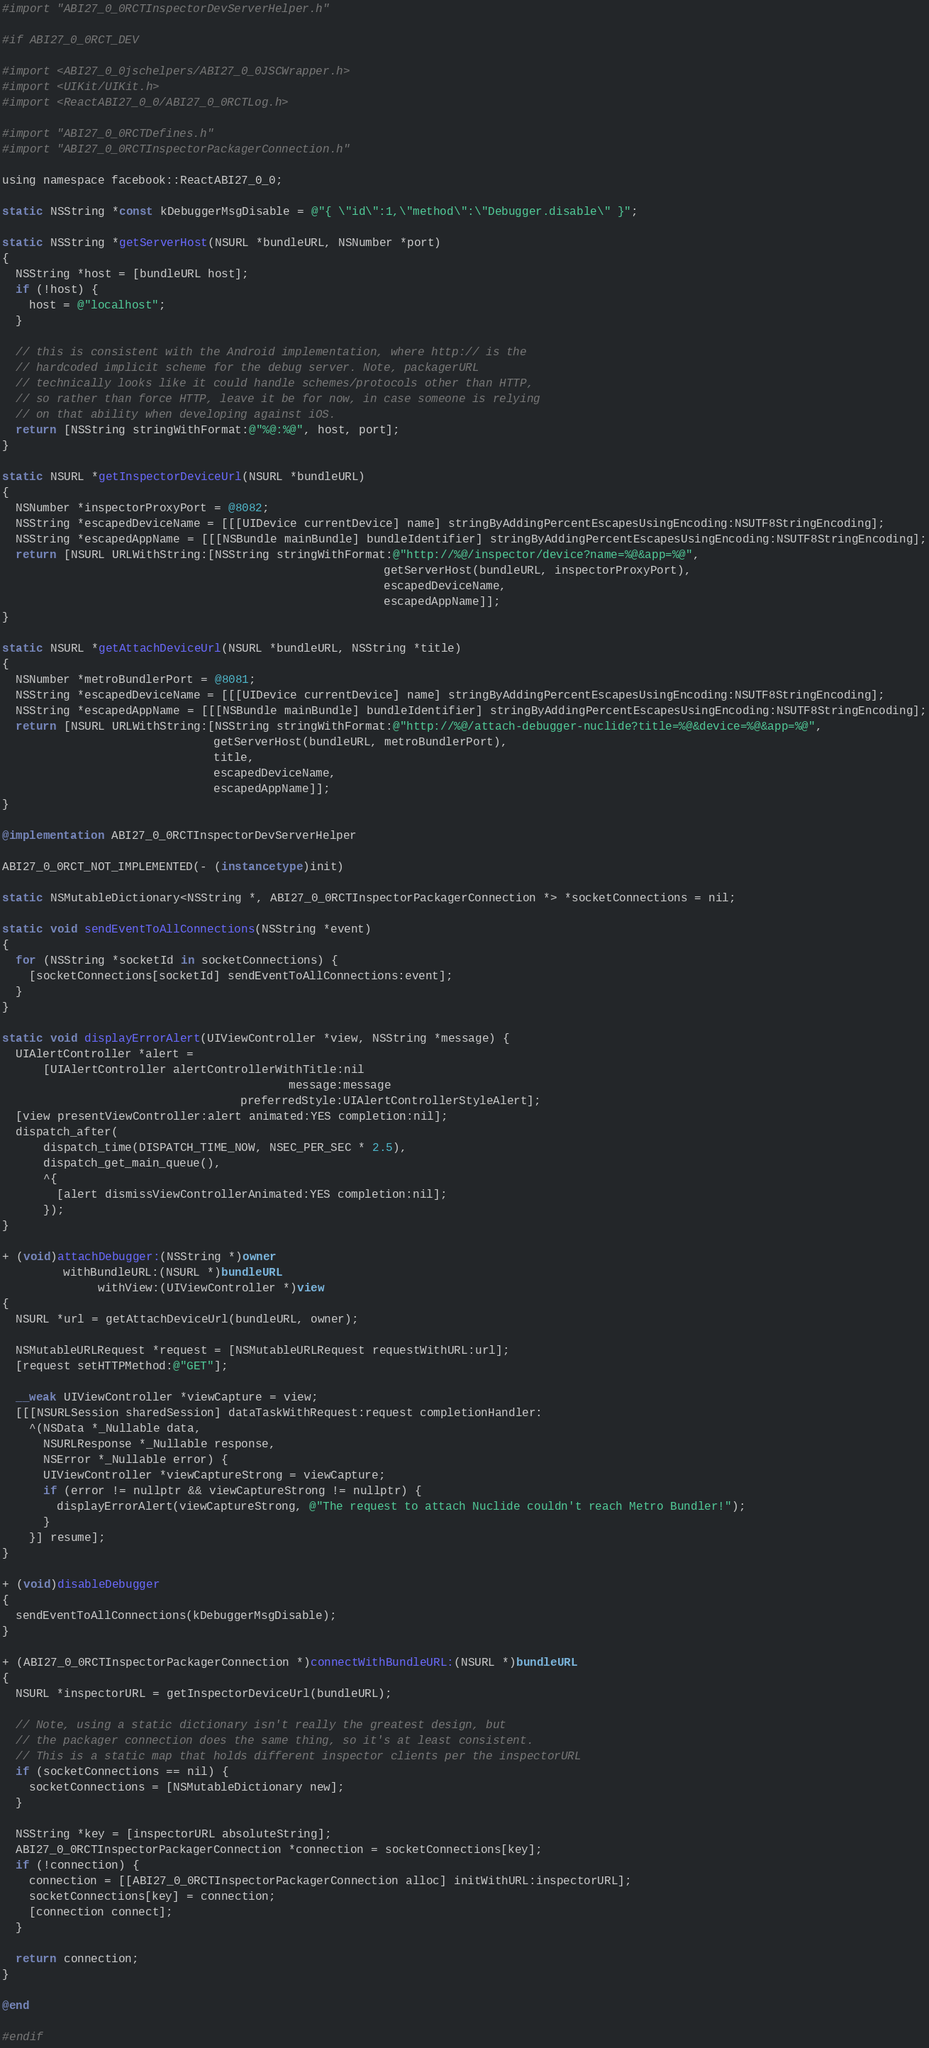<code> <loc_0><loc_0><loc_500><loc_500><_ObjectiveC_>#import "ABI27_0_0RCTInspectorDevServerHelper.h"

#if ABI27_0_0RCT_DEV

#import <ABI27_0_0jschelpers/ABI27_0_0JSCWrapper.h>
#import <UIKit/UIKit.h>
#import <ReactABI27_0_0/ABI27_0_0RCTLog.h>

#import "ABI27_0_0RCTDefines.h"
#import "ABI27_0_0RCTInspectorPackagerConnection.h"

using namespace facebook::ReactABI27_0_0;

static NSString *const kDebuggerMsgDisable = @"{ \"id\":1,\"method\":\"Debugger.disable\" }";

static NSString *getServerHost(NSURL *bundleURL, NSNumber *port)
{
  NSString *host = [bundleURL host];
  if (!host) {
    host = @"localhost";
  }

  // this is consistent with the Android implementation, where http:// is the
  // hardcoded implicit scheme for the debug server. Note, packagerURL
  // technically looks like it could handle schemes/protocols other than HTTP,
  // so rather than force HTTP, leave it be for now, in case someone is relying
  // on that ability when developing against iOS.
  return [NSString stringWithFormat:@"%@:%@", host, port];
}

static NSURL *getInspectorDeviceUrl(NSURL *bundleURL)
{
  NSNumber *inspectorProxyPort = @8082;
  NSString *escapedDeviceName = [[[UIDevice currentDevice] name] stringByAddingPercentEscapesUsingEncoding:NSUTF8StringEncoding];
  NSString *escapedAppName = [[[NSBundle mainBundle] bundleIdentifier] stringByAddingPercentEscapesUsingEncoding:NSUTF8StringEncoding];
  return [NSURL URLWithString:[NSString stringWithFormat:@"http://%@/inspector/device?name=%@&app=%@",
                                                        getServerHost(bundleURL, inspectorProxyPort),
                                                        escapedDeviceName,
                                                        escapedAppName]];
}

static NSURL *getAttachDeviceUrl(NSURL *bundleURL, NSString *title)
{
  NSNumber *metroBundlerPort = @8081;
  NSString *escapedDeviceName = [[[UIDevice currentDevice] name] stringByAddingPercentEscapesUsingEncoding:NSUTF8StringEncoding];
  NSString *escapedAppName = [[[NSBundle mainBundle] bundleIdentifier] stringByAddingPercentEscapesUsingEncoding:NSUTF8StringEncoding];
  return [NSURL URLWithString:[NSString stringWithFormat:@"http://%@/attach-debugger-nuclide?title=%@&device=%@&app=%@",
                               getServerHost(bundleURL, metroBundlerPort),
                               title,
                               escapedDeviceName,
                               escapedAppName]];
}

@implementation ABI27_0_0RCTInspectorDevServerHelper

ABI27_0_0RCT_NOT_IMPLEMENTED(- (instancetype)init)

static NSMutableDictionary<NSString *, ABI27_0_0RCTInspectorPackagerConnection *> *socketConnections = nil;

static void sendEventToAllConnections(NSString *event)
{
  for (NSString *socketId in socketConnections) {
    [socketConnections[socketId] sendEventToAllConnections:event];
  }
}

static void displayErrorAlert(UIViewController *view, NSString *message) {
  UIAlertController *alert =
      [UIAlertController alertControllerWithTitle:nil
                                          message:message
                                   preferredStyle:UIAlertControllerStyleAlert];
  [view presentViewController:alert animated:YES completion:nil];
  dispatch_after(
      dispatch_time(DISPATCH_TIME_NOW, NSEC_PER_SEC * 2.5),
      dispatch_get_main_queue(),
      ^{
        [alert dismissViewControllerAnimated:YES completion:nil];
      });
}

+ (void)attachDebugger:(NSString *)owner
         withBundleURL:(NSURL *)bundleURL
              withView:(UIViewController *)view
{
  NSURL *url = getAttachDeviceUrl(bundleURL, owner);

  NSMutableURLRequest *request = [NSMutableURLRequest requestWithURL:url];
  [request setHTTPMethod:@"GET"];

  __weak UIViewController *viewCapture = view;
  [[[NSURLSession sharedSession] dataTaskWithRequest:request completionHandler:
    ^(NSData *_Nullable data,
      NSURLResponse *_Nullable response,
      NSError *_Nullable error) {
      UIViewController *viewCaptureStrong = viewCapture;
      if (error != nullptr && viewCaptureStrong != nullptr) {
        displayErrorAlert(viewCaptureStrong, @"The request to attach Nuclide couldn't reach Metro Bundler!");
      }
    }] resume];
}

+ (void)disableDebugger
{
  sendEventToAllConnections(kDebuggerMsgDisable);
}

+ (ABI27_0_0RCTInspectorPackagerConnection *)connectWithBundleURL:(NSURL *)bundleURL
{
  NSURL *inspectorURL = getInspectorDeviceUrl(bundleURL);

  // Note, using a static dictionary isn't really the greatest design, but
  // the packager connection does the same thing, so it's at least consistent.
  // This is a static map that holds different inspector clients per the inspectorURL
  if (socketConnections == nil) {
    socketConnections = [NSMutableDictionary new];
  }

  NSString *key = [inspectorURL absoluteString];
  ABI27_0_0RCTInspectorPackagerConnection *connection = socketConnections[key];
  if (!connection) {
    connection = [[ABI27_0_0RCTInspectorPackagerConnection alloc] initWithURL:inspectorURL];
    socketConnections[key] = connection;
    [connection connect];
  }

  return connection;
}

@end

#endif
</code> 